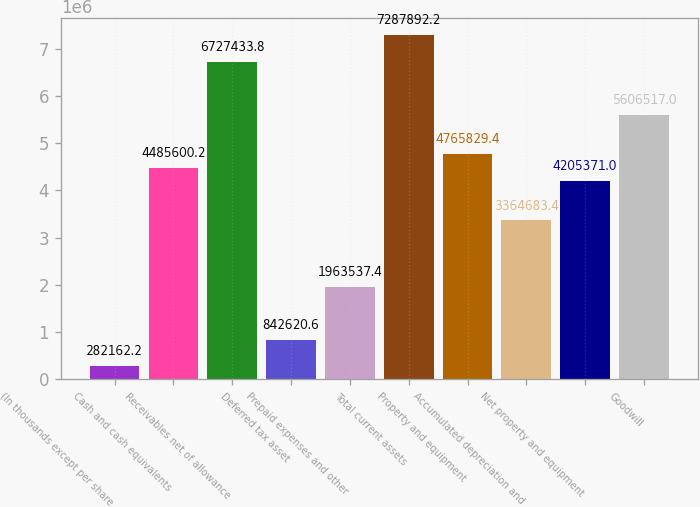Convert chart to OTSL. <chart><loc_0><loc_0><loc_500><loc_500><bar_chart><fcel>(In thousands except per share<fcel>Cash and cash equivalents<fcel>Receivables net of allowance<fcel>Deferred tax asset<fcel>Prepaid expenses and other<fcel>Total current assets<fcel>Property and equipment<fcel>Accumulated depreciation and<fcel>Net property and equipment<fcel>Goodwill<nl><fcel>282162<fcel>4.4856e+06<fcel>6.72743e+06<fcel>842621<fcel>1.96354e+06<fcel>7.28789e+06<fcel>4.76583e+06<fcel>3.36468e+06<fcel>4.20537e+06<fcel>5.60652e+06<nl></chart> 